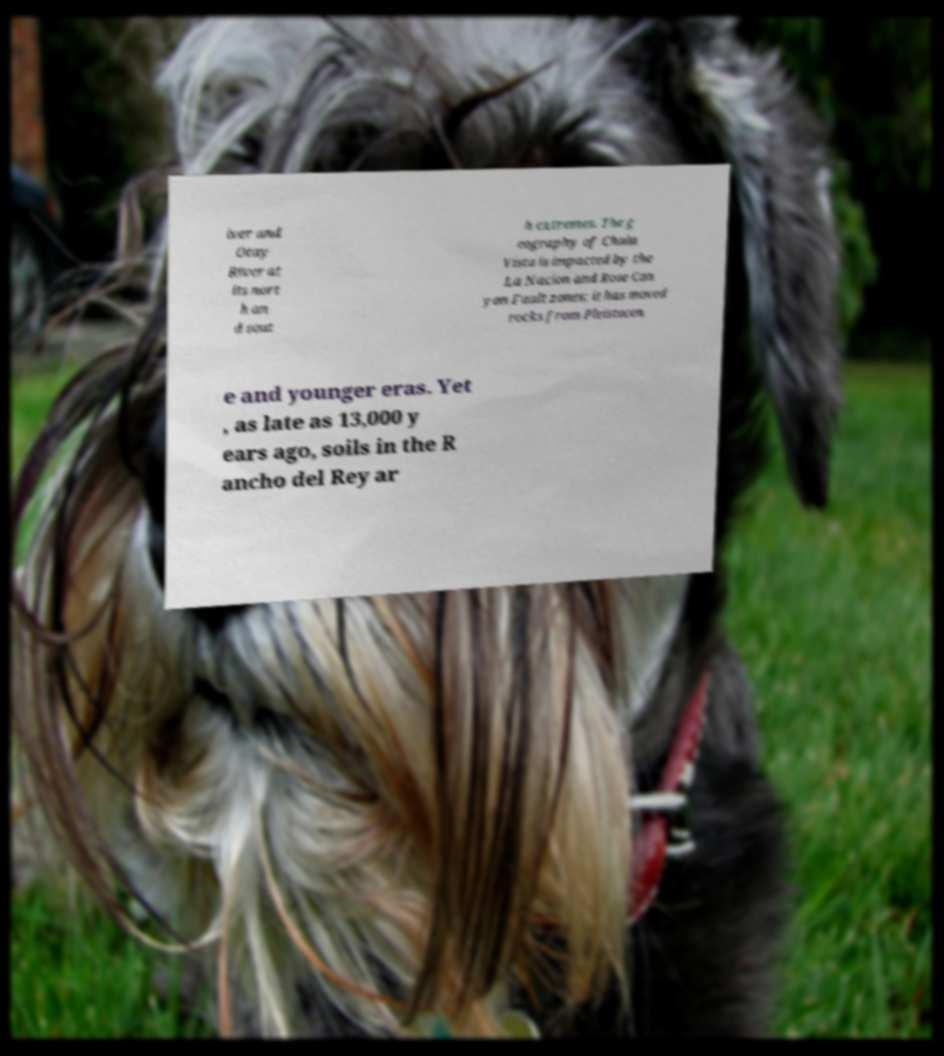Can you read and provide the text displayed in the image?This photo seems to have some interesting text. Can you extract and type it out for me? iver and Otay River at its nort h an d sout h extremes. The g eography of Chula Vista is impacted by the La Nacion and Rose Can yon Fault zones; it has moved rocks from Pleistocen e and younger eras. Yet , as late as 13,000 y ears ago, soils in the R ancho del Rey ar 